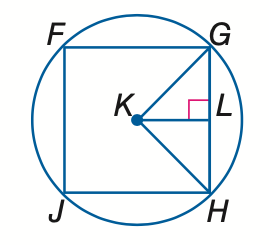Answer the mathemtical geometry problem and directly provide the correct option letter.
Question: Square F G H J is inscribed in \odot K. Find the measure of a central angle.
Choices: A: 45 B: 60 C: 90 D: 180 C 